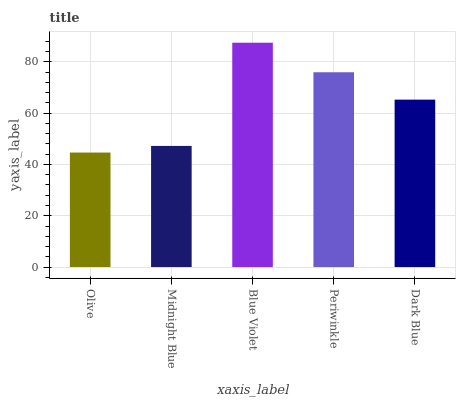Is Olive the minimum?
Answer yes or no. Yes. Is Blue Violet the maximum?
Answer yes or no. Yes. Is Midnight Blue the minimum?
Answer yes or no. No. Is Midnight Blue the maximum?
Answer yes or no. No. Is Midnight Blue greater than Olive?
Answer yes or no. Yes. Is Olive less than Midnight Blue?
Answer yes or no. Yes. Is Olive greater than Midnight Blue?
Answer yes or no. No. Is Midnight Blue less than Olive?
Answer yes or no. No. Is Dark Blue the high median?
Answer yes or no. Yes. Is Dark Blue the low median?
Answer yes or no. Yes. Is Olive the high median?
Answer yes or no. No. Is Olive the low median?
Answer yes or no. No. 